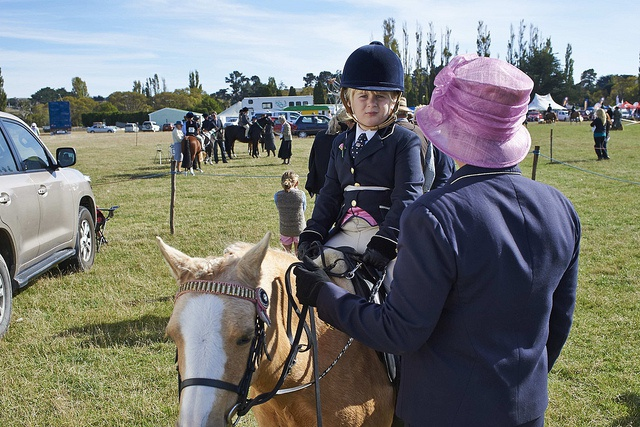Describe the objects in this image and their specific colors. I can see people in lightblue, black, navy, purple, and violet tones, horse in lightblue, maroon, black, gray, and darkgray tones, people in lightblue, black, darkgray, and gray tones, car in lightblue, darkgray, lightgray, black, and gray tones, and people in lightblue, gray, black, and darkgray tones in this image. 